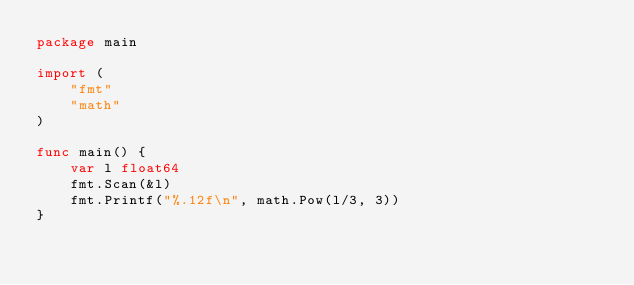Convert code to text. <code><loc_0><loc_0><loc_500><loc_500><_Go_>package main

import (
	"fmt"
	"math"
)

func main() {
	var l float64
	fmt.Scan(&l)
	fmt.Printf("%.12f\n", math.Pow(l/3, 3))
}
</code> 